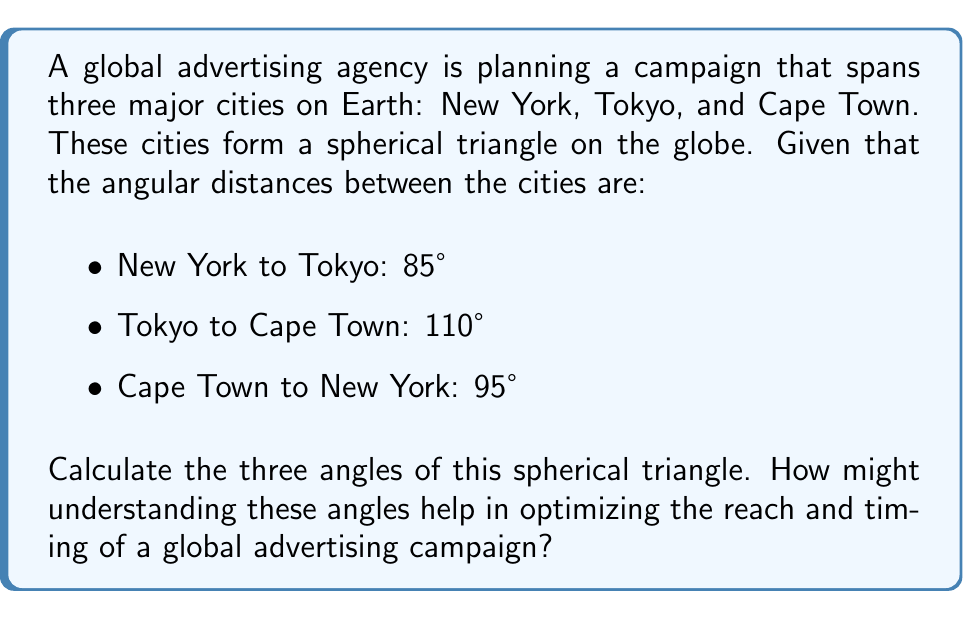Help me with this question. To solve this problem, we'll use the spherical law of cosines. Let's denote the angles as follows:
- A: angle at New York
- B: angle at Tokyo
- C: angle at Cape Town

And the sides:
- a: Tokyo to Cape Town (110°)
- b: Cape Town to New York (95°)
- c: New York to Tokyo (85°)

Step 1: Use the spherical law of cosines for each angle:

$$\cos A = \frac{\cos a - \cos b \cos c}{\sin b \sin c}$$
$$\cos B = \frac{\cos b - \cos c \cos a}{\sin c \sin a}$$
$$\cos C = \frac{\cos c - \cos a \cos b}{\sin a \sin b}$$

Step 2: Calculate each angle:

For angle A (New York):
$$\cos A = \frac{\cos 110° - \cos 95° \cos 85°}{\sin 95° \sin 85°} \approx -0.5066$$
$$A = \arccos(-0.5066) \approx 120.4°$$

For angle B (Tokyo):
$$\cos B = \frac{\cos 95° - \cos 85° \cos 110°}{\sin 85° \sin 110°} \approx 0.1710$$
$$B = \arccos(0.1710) \approx 80.2°$$

For angle C (Cape Town):
$$\cos C = \frac{\cos 85° - \cos 110° \cos 95°}{\sin 110° \sin 95°} \approx 0.2588$$
$$C = \arccos(0.2588) \approx 75.0°$$

Step 3: Verify that the sum of angles is greater than 180°, which is a property of spherical triangles:

$$120.4° + 80.2° + 75.0° = 275.6°$$

Understanding these angles can help optimize a global advertising campaign in several ways:

1. Time zone considerations: The angles represent the "spread" between cities, which correlates with time differences. This can help in planning synchronized ad releases or staggered campaigns.

2. Cultural influence zones: The size of each angle might indicate the relative cultural influence of each city in the global context, helping to prioritize content creation and localization efforts.

3. Network effect modeling: The angles can be used to model how information or trends might spread between these major hubs, informing strategies for viral or word-of-mouth campaigns.

4. Resource allocation: Understanding the geometric relationship between these cities can guide the distribution of advertising resources and personnel across global offices.

5. Travel and logistics planning: For physical events or coordinated launches, these angles provide insight into the most efficient travel routes and timing for global teams.
Answer: A ≈ 120.4°, B ≈ 80.2°, C ≈ 75.0°. Understanding aids in time zone planning, cultural influence mapping, network effect modeling, resource allocation, and global logistics optimization. 